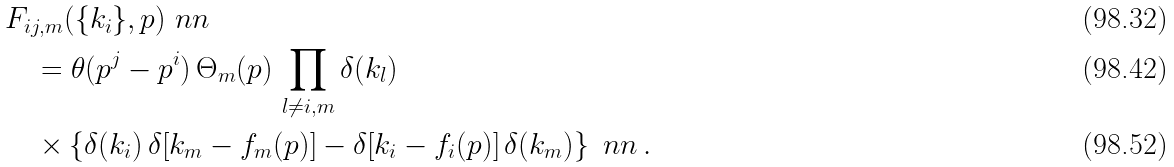Convert formula to latex. <formula><loc_0><loc_0><loc_500><loc_500>& F _ { i j , m } ( \{ k _ { i } \} , p ) \ n n \\ & \quad = \theta ( p ^ { j } - p ^ { i } ) \, \Theta _ { m } ( p ) \, \prod _ { l \neq i , m } \delta ( k _ { l } ) \\ & \quad \times \left \{ \delta ( k _ { i } ) \, \delta [ k _ { m } - f _ { m } ( p ) ] - \delta [ k _ { i } - f _ { i } ( p ) ] \, \delta ( k _ { m } ) \right \} \ n n \, .</formula> 